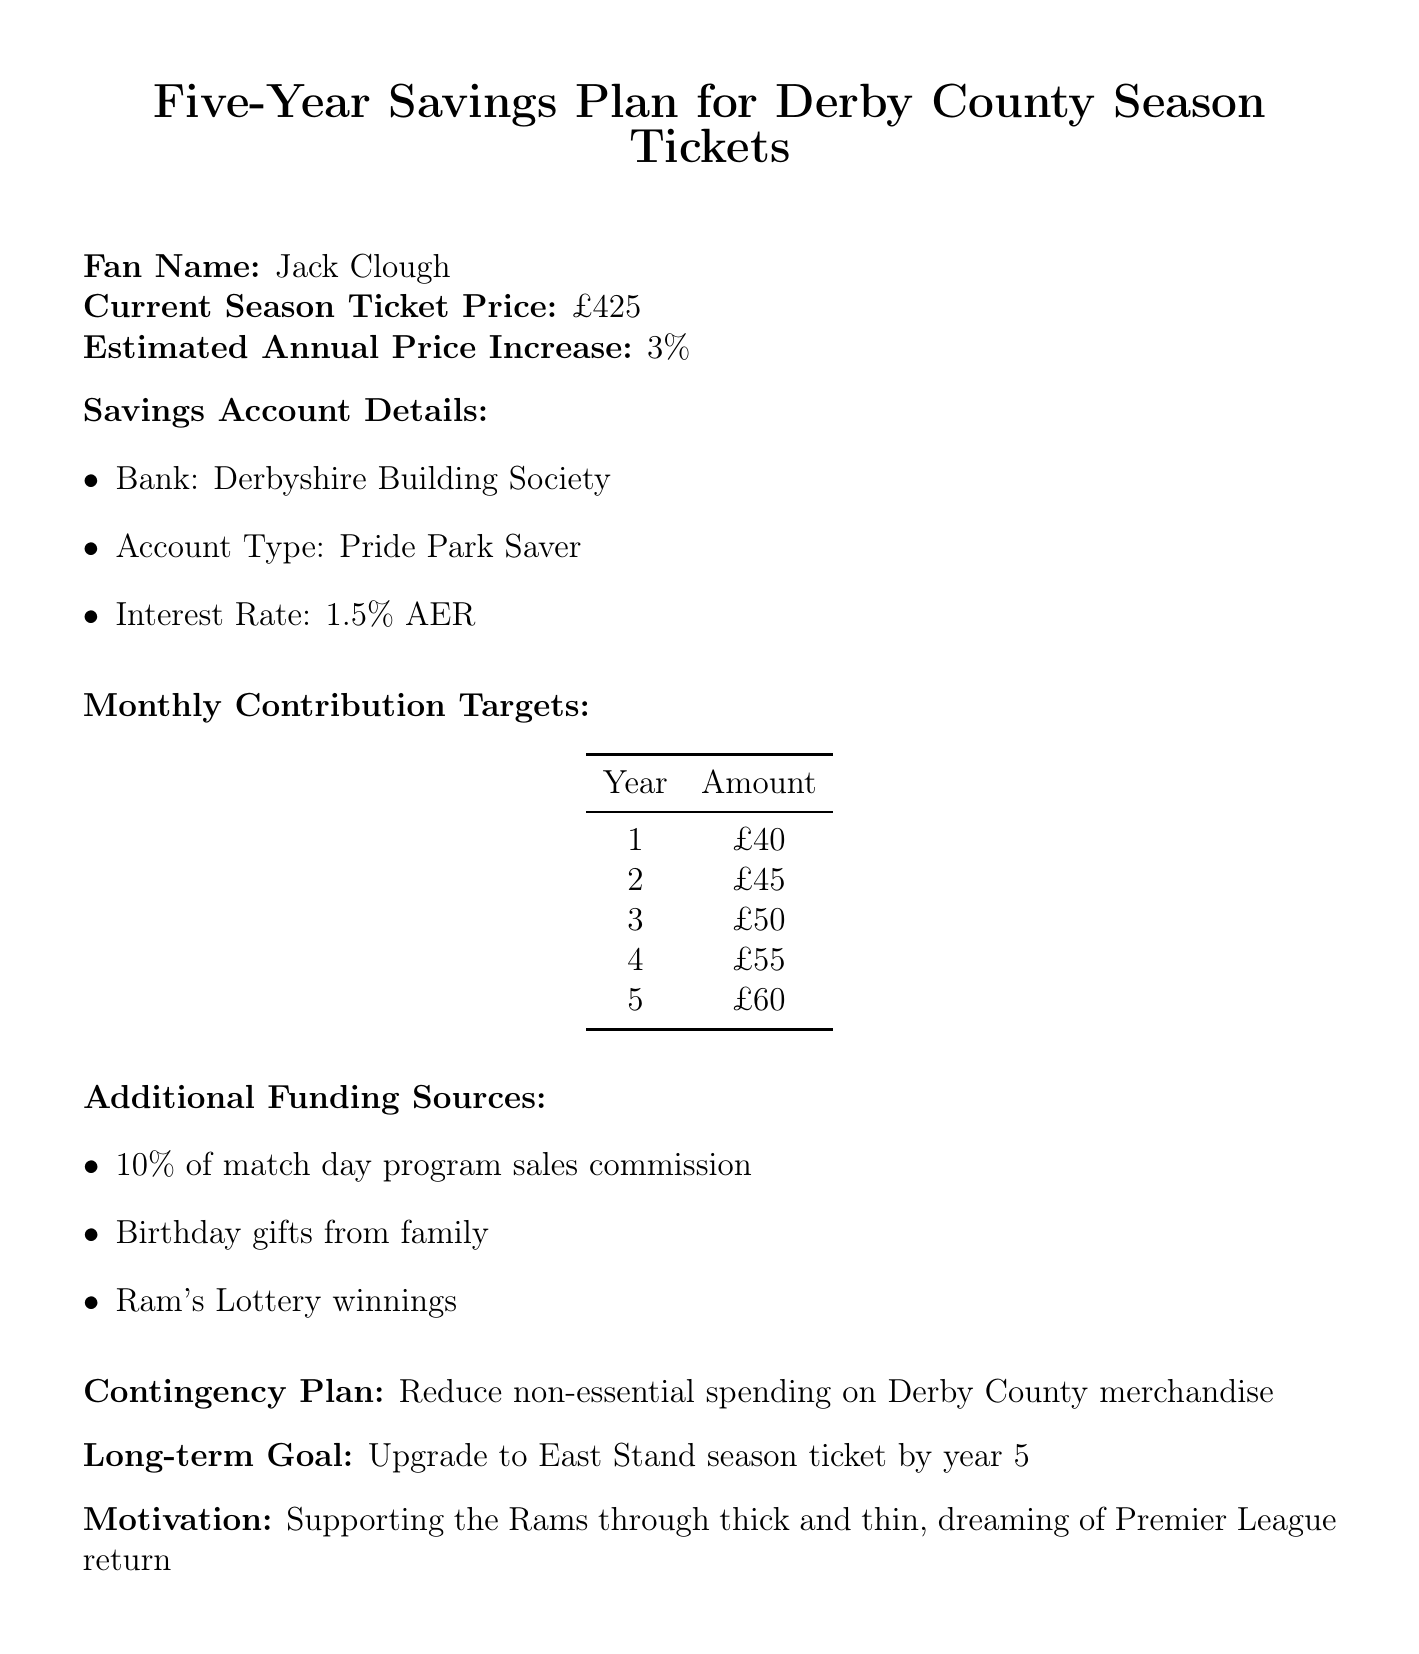What is the current season ticket price? The document states the current season ticket price is £425.
Answer: £425 What is the estimated annual price increase? The report indicates an estimated annual price increase of 3%.
Answer: 3% Who is the fan named in the document? The document lists "Jack Clough" as the fan's name.
Answer: Jack Clough What is the interest rate for the savings account? The savings account has an interest rate of 1.5% AER as mentioned in the document.
Answer: 1.5% AER How much is the monthly contribution target in year 3? The document specifies that the monthly contribution target for year 3 is £50.
Answer: £50 What is the long-term goal stated in the plan? The long-term goal in the document is to upgrade to an East Stand season ticket by year 5.
Answer: Upgrade to East Stand season ticket by year 5 What are two additional funding sources listed? The report lists match day program sales commission and birthday gifts from family as additional funding sources.
Answer: 10% of match day program sales commission, Birthday gifts from family What is the contingency plan? The document mentions that the contingency plan is to reduce non-essential spending on Derby County merchandise.
Answer: Reduce non-essential spending on Derby County merchandise What is the estimated monthly contribution target for year 5? According to the document, the estimated monthly contribution target for year 5 is £60.
Answer: £60 